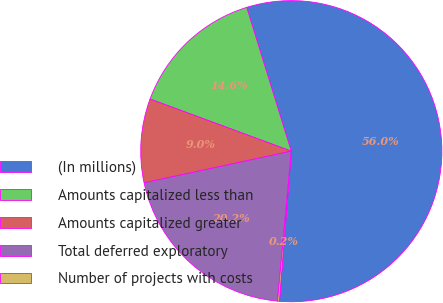<chart> <loc_0><loc_0><loc_500><loc_500><pie_chart><fcel>(In millions)<fcel>Amounts capitalized less than<fcel>Amounts capitalized greater<fcel>Total deferred exploratory<fcel>Number of projects with costs<nl><fcel>56.04%<fcel>14.59%<fcel>9.0%<fcel>20.17%<fcel>0.2%<nl></chart> 